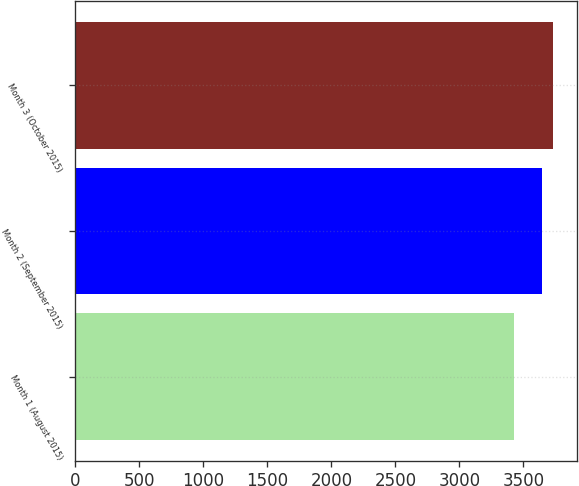Convert chart to OTSL. <chart><loc_0><loc_0><loc_500><loc_500><bar_chart><fcel>Month 1 (August 2015)<fcel>Month 2 (September 2015)<fcel>Month 3 (October 2015)<nl><fcel>3429<fcel>3641<fcel>3732<nl></chart> 